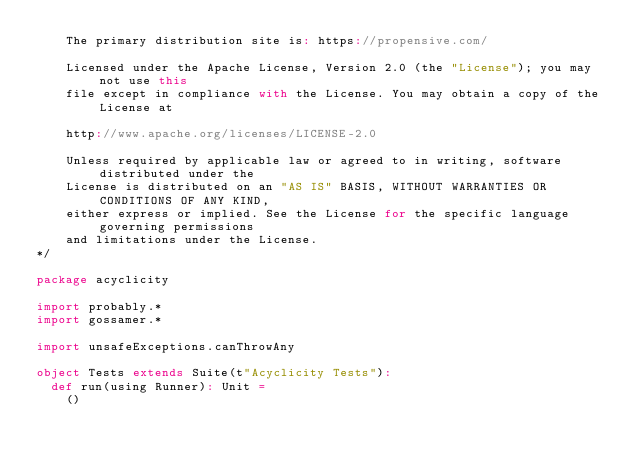Convert code to text. <code><loc_0><loc_0><loc_500><loc_500><_Scala_>    The primary distribution site is: https://propensive.com/

    Licensed under the Apache License, Version 2.0 (the "License"); you may not use this
    file except in compliance with the License. You may obtain a copy of the License at

    http://www.apache.org/licenses/LICENSE-2.0

    Unless required by applicable law or agreed to in writing, software distributed under the
    License is distributed on an "AS IS" BASIS, WITHOUT WARRANTIES OR CONDITIONS OF ANY KIND,
    either express or implied. See the License for the specific language governing permissions
    and limitations under the License.
*/

package acyclicity

import probably.*
import gossamer.*

import unsafeExceptions.canThrowAny

object Tests extends Suite(t"Acyclicity Tests"):
  def run(using Runner): Unit =
    ()
</code> 